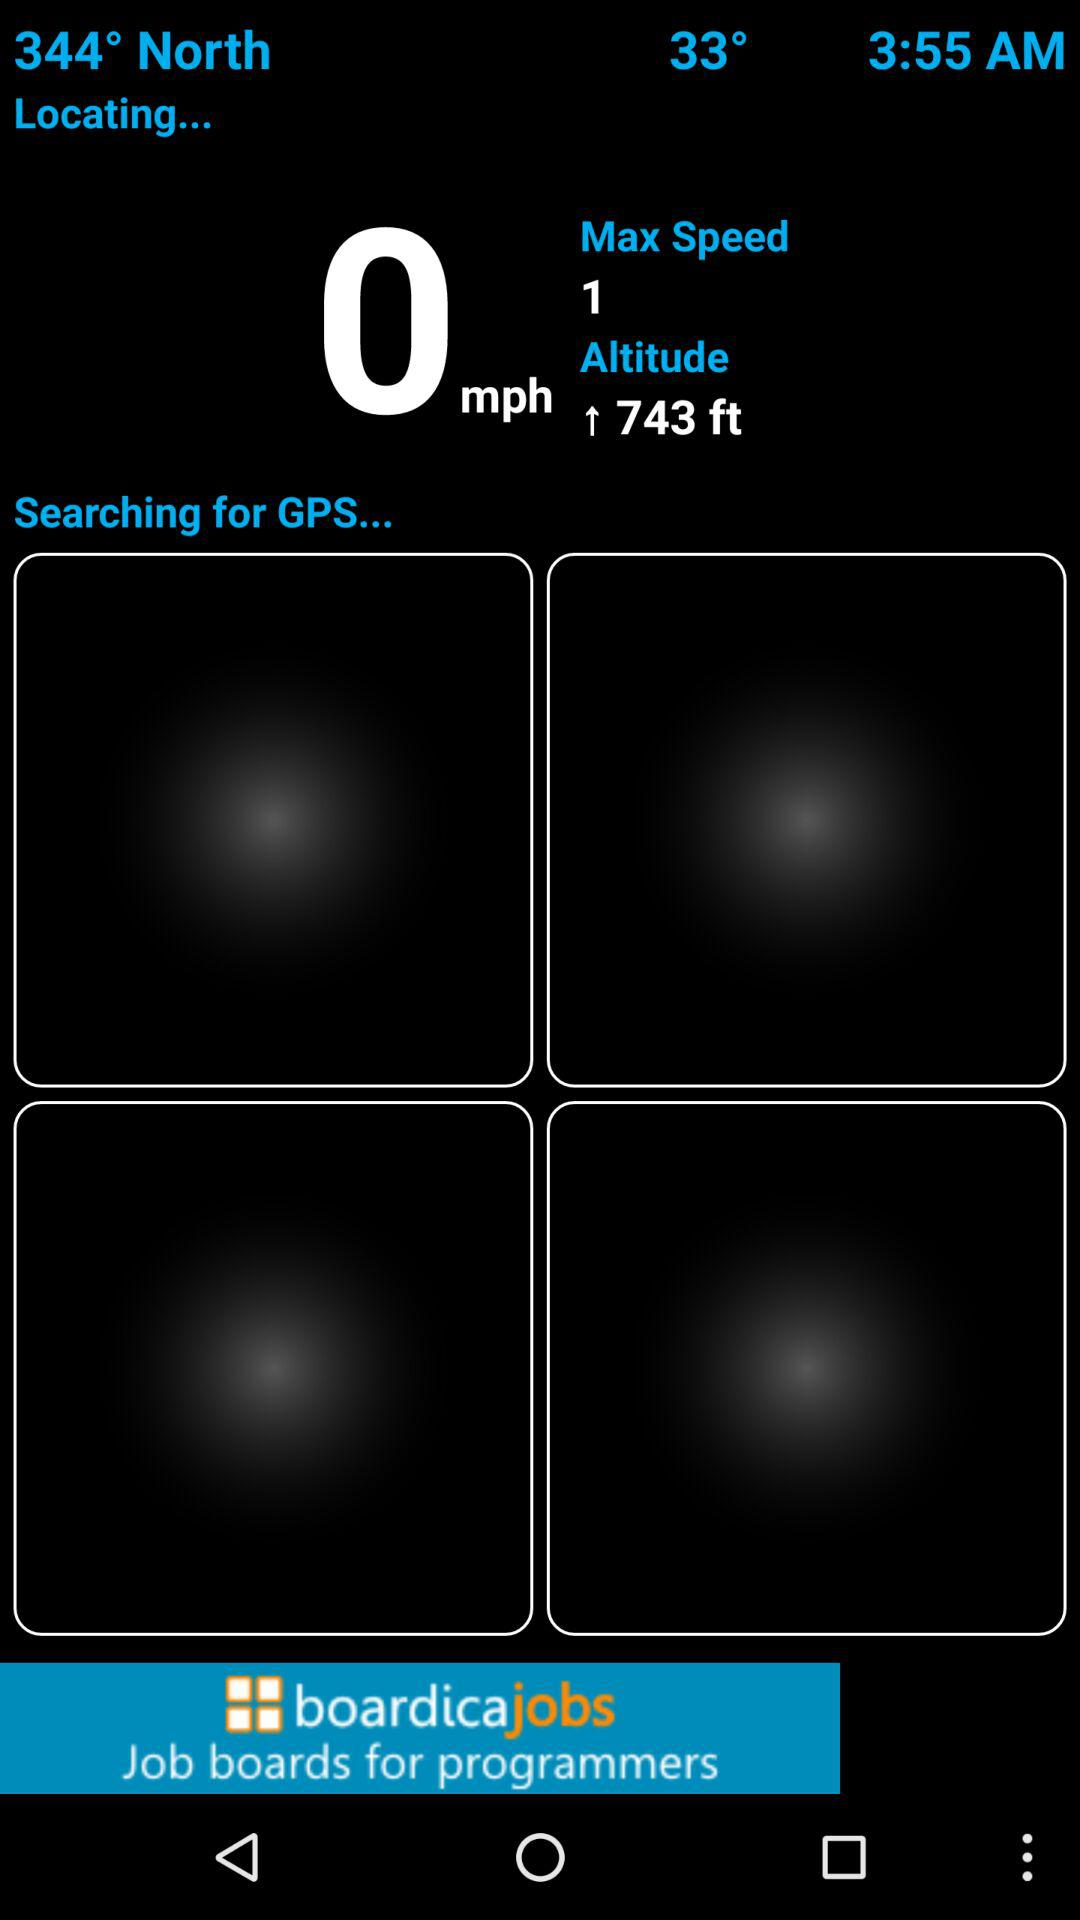What is the altitude? The altitude is 743 feet. 